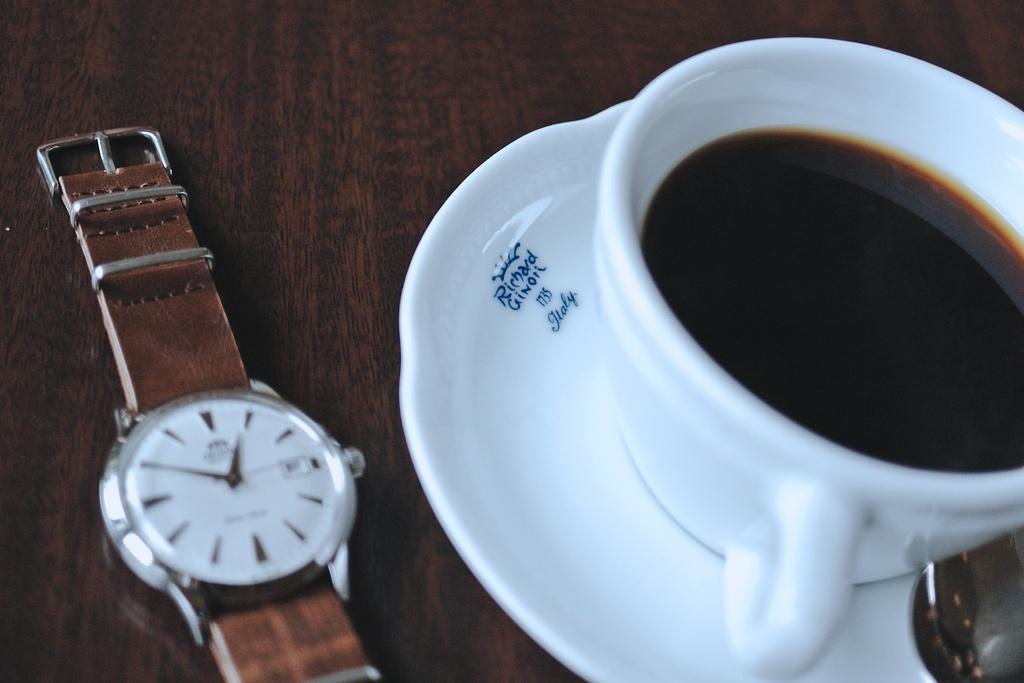Provide a one-sentence caption for the provided image. A watch is next to a cup of coffee and saucer that says Richard Ginori 1735 Italy. 